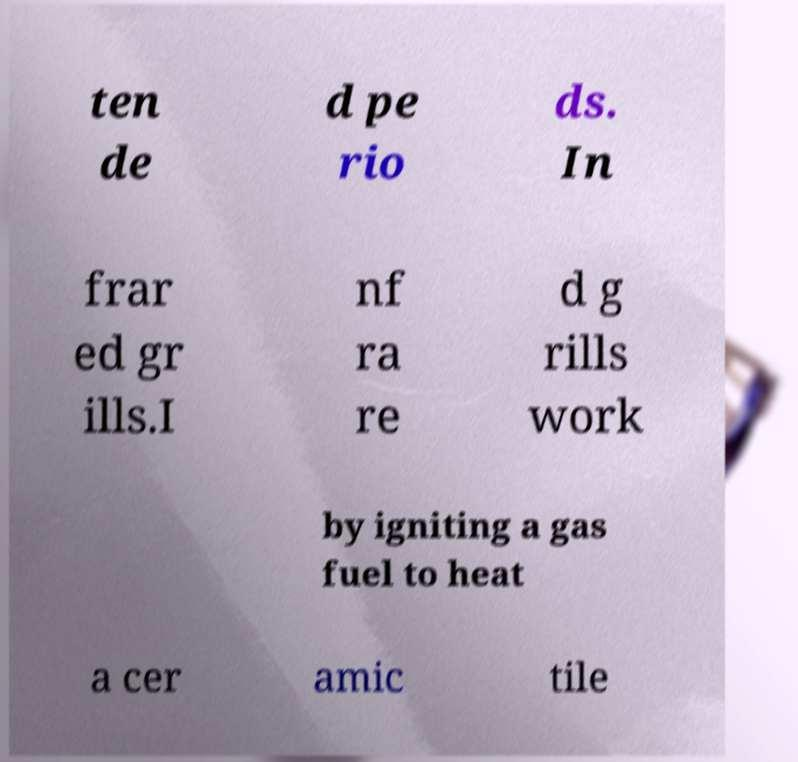I need the written content from this picture converted into text. Can you do that? ten de d pe rio ds. In frar ed gr ills.I nf ra re d g rills work by igniting a gas fuel to heat a cer amic tile 